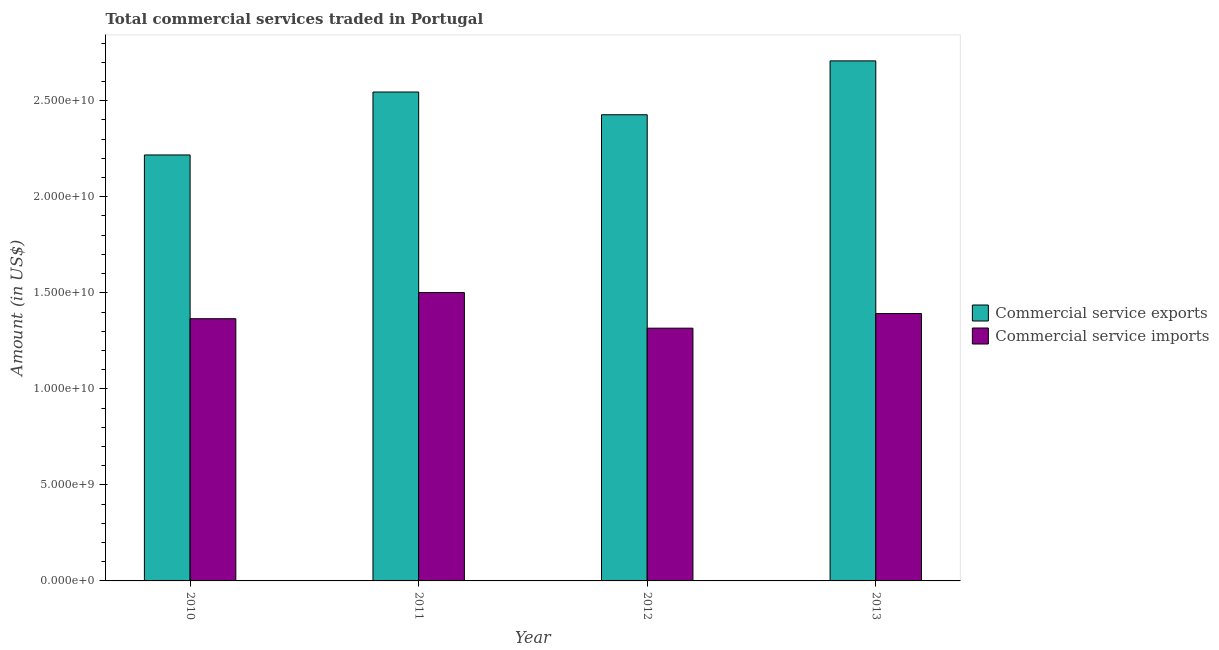How many groups of bars are there?
Offer a very short reply. 4. How many bars are there on the 4th tick from the left?
Keep it short and to the point. 2. How many bars are there on the 2nd tick from the right?
Offer a terse response. 2. What is the label of the 4th group of bars from the left?
Your answer should be very brief. 2013. In how many cases, is the number of bars for a given year not equal to the number of legend labels?
Provide a succinct answer. 0. What is the amount of commercial service exports in 2012?
Your response must be concise. 2.43e+1. Across all years, what is the maximum amount of commercial service exports?
Offer a very short reply. 2.71e+1. Across all years, what is the minimum amount of commercial service imports?
Offer a terse response. 1.32e+1. In which year was the amount of commercial service imports minimum?
Provide a short and direct response. 2012. What is the total amount of commercial service imports in the graph?
Provide a succinct answer. 5.57e+1. What is the difference between the amount of commercial service imports in 2010 and that in 2011?
Offer a terse response. -1.36e+09. What is the difference between the amount of commercial service imports in 2012 and the amount of commercial service exports in 2011?
Make the answer very short. -1.85e+09. What is the average amount of commercial service exports per year?
Give a very brief answer. 2.47e+1. In the year 2011, what is the difference between the amount of commercial service exports and amount of commercial service imports?
Make the answer very short. 0. In how many years, is the amount of commercial service exports greater than 18000000000 US$?
Provide a short and direct response. 4. What is the ratio of the amount of commercial service exports in 2010 to that in 2011?
Your response must be concise. 0.87. What is the difference between the highest and the second highest amount of commercial service imports?
Make the answer very short. 1.09e+09. What is the difference between the highest and the lowest amount of commercial service imports?
Give a very brief answer. 1.85e+09. In how many years, is the amount of commercial service exports greater than the average amount of commercial service exports taken over all years?
Your answer should be compact. 2. Is the sum of the amount of commercial service imports in 2011 and 2013 greater than the maximum amount of commercial service exports across all years?
Offer a very short reply. Yes. What does the 1st bar from the left in 2011 represents?
Keep it short and to the point. Commercial service exports. What does the 1st bar from the right in 2011 represents?
Your answer should be compact. Commercial service imports. How many years are there in the graph?
Offer a very short reply. 4. What is the difference between two consecutive major ticks on the Y-axis?
Make the answer very short. 5.00e+09. Does the graph contain grids?
Keep it short and to the point. No. Where does the legend appear in the graph?
Offer a terse response. Center right. What is the title of the graph?
Your response must be concise. Total commercial services traded in Portugal. What is the label or title of the X-axis?
Ensure brevity in your answer.  Year. What is the label or title of the Y-axis?
Offer a terse response. Amount (in US$). What is the Amount (in US$) of Commercial service exports in 2010?
Your answer should be compact. 2.22e+1. What is the Amount (in US$) of Commercial service imports in 2010?
Offer a very short reply. 1.37e+1. What is the Amount (in US$) of Commercial service exports in 2011?
Offer a terse response. 2.55e+1. What is the Amount (in US$) in Commercial service imports in 2011?
Your answer should be very brief. 1.50e+1. What is the Amount (in US$) in Commercial service exports in 2012?
Ensure brevity in your answer.  2.43e+1. What is the Amount (in US$) of Commercial service imports in 2012?
Provide a succinct answer. 1.32e+1. What is the Amount (in US$) in Commercial service exports in 2013?
Your answer should be compact. 2.71e+1. What is the Amount (in US$) in Commercial service imports in 2013?
Make the answer very short. 1.39e+1. Across all years, what is the maximum Amount (in US$) of Commercial service exports?
Give a very brief answer. 2.71e+1. Across all years, what is the maximum Amount (in US$) of Commercial service imports?
Ensure brevity in your answer.  1.50e+1. Across all years, what is the minimum Amount (in US$) in Commercial service exports?
Make the answer very short. 2.22e+1. Across all years, what is the minimum Amount (in US$) of Commercial service imports?
Ensure brevity in your answer.  1.32e+1. What is the total Amount (in US$) of Commercial service exports in the graph?
Your response must be concise. 9.90e+1. What is the total Amount (in US$) of Commercial service imports in the graph?
Give a very brief answer. 5.57e+1. What is the difference between the Amount (in US$) of Commercial service exports in 2010 and that in 2011?
Give a very brief answer. -3.28e+09. What is the difference between the Amount (in US$) of Commercial service imports in 2010 and that in 2011?
Keep it short and to the point. -1.36e+09. What is the difference between the Amount (in US$) in Commercial service exports in 2010 and that in 2012?
Make the answer very short. -2.09e+09. What is the difference between the Amount (in US$) of Commercial service imports in 2010 and that in 2012?
Offer a very short reply. 4.93e+08. What is the difference between the Amount (in US$) in Commercial service exports in 2010 and that in 2013?
Provide a short and direct response. -4.90e+09. What is the difference between the Amount (in US$) of Commercial service imports in 2010 and that in 2013?
Offer a terse response. -2.68e+08. What is the difference between the Amount (in US$) in Commercial service exports in 2011 and that in 2012?
Offer a very short reply. 1.18e+09. What is the difference between the Amount (in US$) in Commercial service imports in 2011 and that in 2012?
Provide a succinct answer. 1.85e+09. What is the difference between the Amount (in US$) in Commercial service exports in 2011 and that in 2013?
Make the answer very short. -1.62e+09. What is the difference between the Amount (in US$) in Commercial service imports in 2011 and that in 2013?
Your answer should be compact. 1.09e+09. What is the difference between the Amount (in US$) of Commercial service exports in 2012 and that in 2013?
Make the answer very short. -2.81e+09. What is the difference between the Amount (in US$) of Commercial service imports in 2012 and that in 2013?
Ensure brevity in your answer.  -7.61e+08. What is the difference between the Amount (in US$) in Commercial service exports in 2010 and the Amount (in US$) in Commercial service imports in 2011?
Ensure brevity in your answer.  7.16e+09. What is the difference between the Amount (in US$) of Commercial service exports in 2010 and the Amount (in US$) of Commercial service imports in 2012?
Your answer should be very brief. 9.02e+09. What is the difference between the Amount (in US$) in Commercial service exports in 2010 and the Amount (in US$) in Commercial service imports in 2013?
Provide a succinct answer. 8.26e+09. What is the difference between the Amount (in US$) of Commercial service exports in 2011 and the Amount (in US$) of Commercial service imports in 2012?
Ensure brevity in your answer.  1.23e+1. What is the difference between the Amount (in US$) in Commercial service exports in 2011 and the Amount (in US$) in Commercial service imports in 2013?
Your answer should be very brief. 1.15e+1. What is the difference between the Amount (in US$) in Commercial service exports in 2012 and the Amount (in US$) in Commercial service imports in 2013?
Provide a succinct answer. 1.04e+1. What is the average Amount (in US$) of Commercial service exports per year?
Keep it short and to the point. 2.47e+1. What is the average Amount (in US$) of Commercial service imports per year?
Give a very brief answer. 1.39e+1. In the year 2010, what is the difference between the Amount (in US$) of Commercial service exports and Amount (in US$) of Commercial service imports?
Keep it short and to the point. 8.52e+09. In the year 2011, what is the difference between the Amount (in US$) of Commercial service exports and Amount (in US$) of Commercial service imports?
Your answer should be compact. 1.04e+1. In the year 2012, what is the difference between the Amount (in US$) in Commercial service exports and Amount (in US$) in Commercial service imports?
Provide a short and direct response. 1.11e+1. In the year 2013, what is the difference between the Amount (in US$) in Commercial service exports and Amount (in US$) in Commercial service imports?
Your response must be concise. 1.32e+1. What is the ratio of the Amount (in US$) of Commercial service exports in 2010 to that in 2011?
Provide a succinct answer. 0.87. What is the ratio of the Amount (in US$) of Commercial service imports in 2010 to that in 2011?
Make the answer very short. 0.91. What is the ratio of the Amount (in US$) in Commercial service exports in 2010 to that in 2012?
Your response must be concise. 0.91. What is the ratio of the Amount (in US$) in Commercial service imports in 2010 to that in 2012?
Ensure brevity in your answer.  1.04. What is the ratio of the Amount (in US$) in Commercial service exports in 2010 to that in 2013?
Provide a succinct answer. 0.82. What is the ratio of the Amount (in US$) in Commercial service imports in 2010 to that in 2013?
Provide a succinct answer. 0.98. What is the ratio of the Amount (in US$) in Commercial service exports in 2011 to that in 2012?
Your answer should be compact. 1.05. What is the ratio of the Amount (in US$) in Commercial service imports in 2011 to that in 2012?
Your answer should be compact. 1.14. What is the ratio of the Amount (in US$) of Commercial service exports in 2011 to that in 2013?
Your answer should be compact. 0.94. What is the ratio of the Amount (in US$) of Commercial service imports in 2011 to that in 2013?
Provide a succinct answer. 1.08. What is the ratio of the Amount (in US$) of Commercial service exports in 2012 to that in 2013?
Your answer should be very brief. 0.9. What is the ratio of the Amount (in US$) in Commercial service imports in 2012 to that in 2013?
Offer a terse response. 0.95. What is the difference between the highest and the second highest Amount (in US$) of Commercial service exports?
Provide a succinct answer. 1.62e+09. What is the difference between the highest and the second highest Amount (in US$) of Commercial service imports?
Your answer should be compact. 1.09e+09. What is the difference between the highest and the lowest Amount (in US$) of Commercial service exports?
Offer a very short reply. 4.90e+09. What is the difference between the highest and the lowest Amount (in US$) in Commercial service imports?
Your answer should be compact. 1.85e+09. 